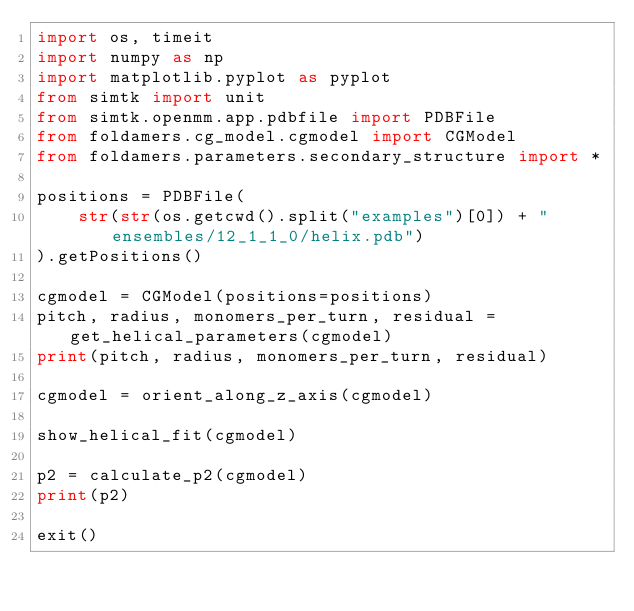Convert code to text. <code><loc_0><loc_0><loc_500><loc_500><_Python_>import os, timeit
import numpy as np
import matplotlib.pyplot as pyplot
from simtk import unit
from simtk.openmm.app.pdbfile import PDBFile
from foldamers.cg_model.cgmodel import CGModel
from foldamers.parameters.secondary_structure import *

positions = PDBFile(
    str(str(os.getcwd().split("examples")[0]) + "ensembles/12_1_1_0/helix.pdb")
).getPositions()

cgmodel = CGModel(positions=positions)
pitch, radius, monomers_per_turn, residual = get_helical_parameters(cgmodel)
print(pitch, radius, monomers_per_turn, residual)

cgmodel = orient_along_z_axis(cgmodel)

show_helical_fit(cgmodel)

p2 = calculate_p2(cgmodel)
print(p2)

exit()
</code> 